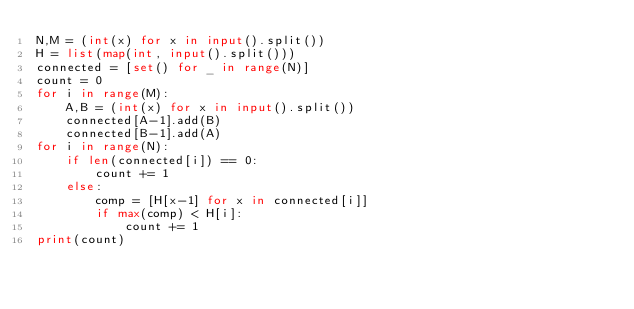<code> <loc_0><loc_0><loc_500><loc_500><_Python_>N,M = (int(x) for x in input().split())
H = list(map(int, input().split()))
connected = [set() for _ in range(N)]
count = 0
for i in range(M):
    A,B = (int(x) for x in input().split())
    connected[A-1].add(B)
    connected[B-1].add(A)
for i in range(N):
    if len(connected[i]) == 0:
        count += 1
    else:
        comp = [H[x-1] for x in connected[i]]
        if max(comp) < H[i]:
            count += 1
print(count)</code> 